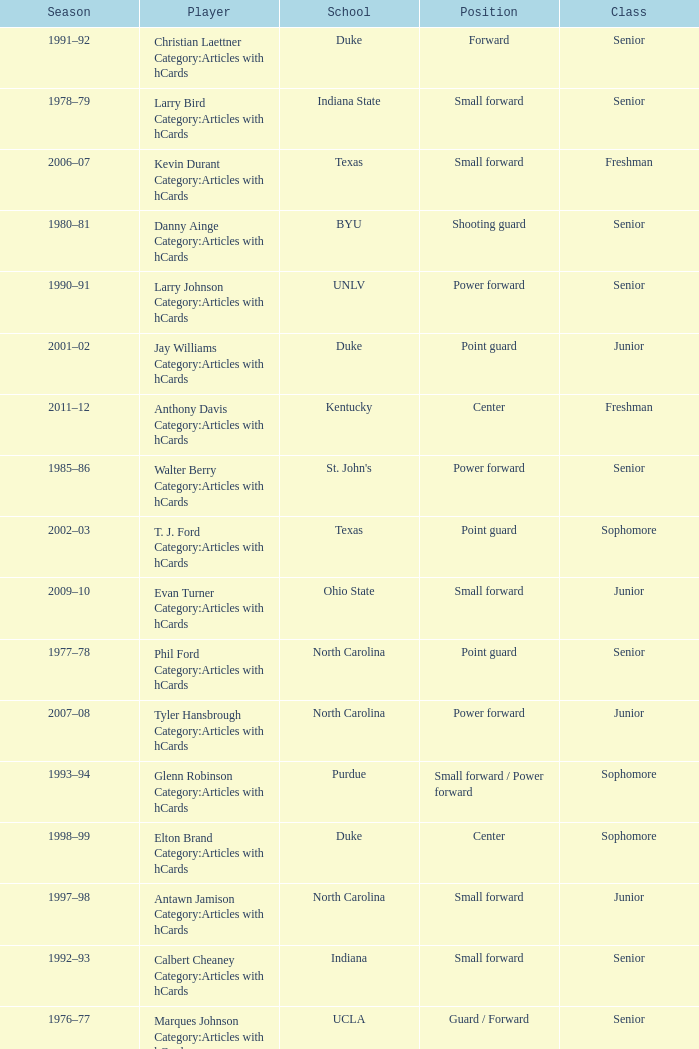Name the position for indiana state Small forward. 